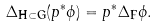Convert formula to latex. <formula><loc_0><loc_0><loc_500><loc_500>\Delta _ { \mathbf H \subset \mathbf G } ( p ^ { * } \phi ) = p ^ { * } \Delta _ { \mathbf F } \phi .</formula> 